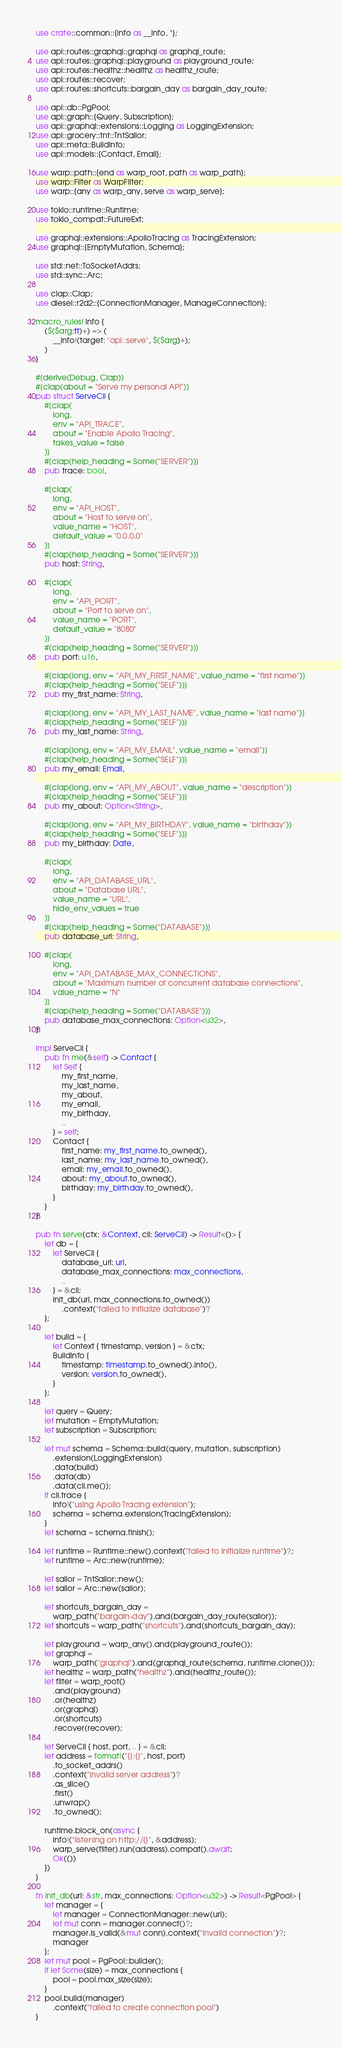<code> <loc_0><loc_0><loc_500><loc_500><_Rust_>use crate::common::{info as __info, *};

use api::routes::graphql::graphql as graphql_route;
use api::routes::graphql::playground as playground_route;
use api::routes::healthz::healthz as healthz_route;
use api::routes::recover;
use api::routes::shortcuts::bargain_day as bargain_day_route;

use api::db::PgPool;
use api::graph::{Query, Subscription};
use api::graphql::extensions::Logging as LoggingExtension;
use api::grocery::tnt::TntSailor;
use api::meta::BuildInfo;
use api::models::{Contact, Email};

use warp::path::{end as warp_root, path as warp_path};
use warp::Filter as WarpFilter;
use warp::{any as warp_any, serve as warp_serve};

use tokio::runtime::Runtime;
use tokio_compat::FutureExt;

use graphql::extensions::ApolloTracing as TracingExtension;
use graphql::{EmptyMutation, Schema};

use std::net::ToSocketAddrs;
use std::sync::Arc;

use clap::Clap;
use diesel::r2d2::{ConnectionManager, ManageConnection};

macro_rules! info {
    ($($arg:tt)+) => (
        __info!(target: "api::serve", $($arg)+);
    )
}

#[derive(Debug, Clap)]
#[clap(about = "Serve my personal API")]
pub struct ServeCli {
    #[clap(
        long,
        env = "API_TRACE",
        about = "Enable Apollo Tracing",
        takes_value = false
    )]
    #[clap(help_heading = Some("SERVER"))]
    pub trace: bool,

    #[clap(
        long,
        env = "API_HOST",
        about = "Host to serve on",
        value_name = "HOST",
        default_value = "0.0.0.0"
    )]
    #[clap(help_heading = Some("SERVER"))]
    pub host: String,

    #[clap(
        long,
        env = "API_PORT",
        about = "Port to serve on",
        value_name = "PORT",
        default_value = "8080"
    )]
    #[clap(help_heading = Some("SERVER"))]
    pub port: u16,

    #[clap(long, env = "API_MY_FIRST_NAME", value_name = "first name")]
    #[clap(help_heading = Some("SELF"))]
    pub my_first_name: String,

    #[clap(long, env = "API_MY_LAST_NAME", value_name = "last name")]
    #[clap(help_heading = Some("SELF"))]
    pub my_last_name: String,

    #[clap(long, env = "API_MY_EMAIL", value_name = "email")]
    #[clap(help_heading = Some("SELF"))]
    pub my_email: Email,

    #[clap(long, env = "API_MY_ABOUT", value_name = "description")]
    #[clap(help_heading = Some("SELF"))]
    pub my_about: Option<String>,

    #[clap(long, env = "API_MY_BIRTHDAY", value_name = "birthday")]
    #[clap(help_heading = Some("SELF"))]
    pub my_birthday: Date,

    #[clap(
        long,
        env = "API_DATABASE_URL",
        about = "Database URL",
        value_name = "URL",
        hide_env_values = true
    )]
    #[clap(help_heading = Some("DATABASE"))]
    pub database_url: String,

    #[clap(
        long,
        env = "API_DATABASE_MAX_CONNECTIONS",
        about = "Maximum number of concurrent database connections",
        value_name = "N"
    )]
    #[clap(help_heading = Some("DATABASE"))]
    pub database_max_connections: Option<u32>,
}

impl ServeCli {
    pub fn me(&self) -> Contact {
        let Self {
            my_first_name,
            my_last_name,
            my_about,
            my_email,
            my_birthday,
            ..
        } = self;
        Contact {
            first_name: my_first_name.to_owned(),
            last_name: my_last_name.to_owned(),
            email: my_email.to_owned(),
            about: my_about.to_owned(),
            birthday: my_birthday.to_owned(),
        }
    }
}

pub fn serve(ctx: &Context, cli: ServeCli) -> Result<()> {
    let db = {
        let ServeCli {
            database_url: url,
            database_max_connections: max_connections,
            ..
        } = &cli;
        init_db(url, max_connections.to_owned())
            .context("failed to initialize database")?
    };

    let build = {
        let Context { timestamp, version } = &ctx;
        BuildInfo {
            timestamp: timestamp.to_owned().into(),
            version: version.to_owned(),
        }
    };

    let query = Query;
    let mutation = EmptyMutation;
    let subscription = Subscription;

    let mut schema = Schema::build(query, mutation, subscription)
        .extension(LoggingExtension)
        .data(build)
        .data(db)
        .data(cli.me());
    if cli.trace {
        info!("using Apollo Tracing extension");
        schema = schema.extension(TracingExtension);
    }
    let schema = schema.finish();

    let runtime = Runtime::new().context("failed to initialize runtime")?;
    let runtime = Arc::new(runtime);

    let sailor = TntSailor::new();
    let sailor = Arc::new(sailor);

    let shortcuts_bargain_day =
        warp_path("bargain-day").and(bargain_day_route(sailor));
    let shortcuts = warp_path("shortcuts").and(shortcuts_bargain_day);

    let playground = warp_any().and(playground_route());
    let graphql =
        warp_path("graphql").and(graphql_route(schema, runtime.clone()));
    let healthz = warp_path("healthz").and(healthz_route());
    let filter = warp_root()
        .and(playground)
        .or(healthz)
        .or(graphql)
        .or(shortcuts)
        .recover(recover);

    let ServeCli { host, port, .. } = &cli;
    let address = format!("{}:{}", host, port)
        .to_socket_addrs()
        .context("invalid server address")?
        .as_slice()
        .first()
        .unwrap()
        .to_owned();

    runtime.block_on(async {
        info!("listening on http://{}", &address);
        warp_serve(filter).run(address).compat().await;
        Ok(())
    })
}

fn init_db(url: &str, max_connections: Option<u32>) -> Result<PgPool> {
    let manager = {
        let manager = ConnectionManager::new(url);
        let mut conn = manager.connect()?;
        manager.is_valid(&mut conn).context("invalid connection")?;
        manager
    };
    let mut pool = PgPool::builder();
    if let Some(size) = max_connections {
        pool = pool.max_size(size);
    }
    pool.build(manager)
        .context("failed to create connection pool")
}
</code> 